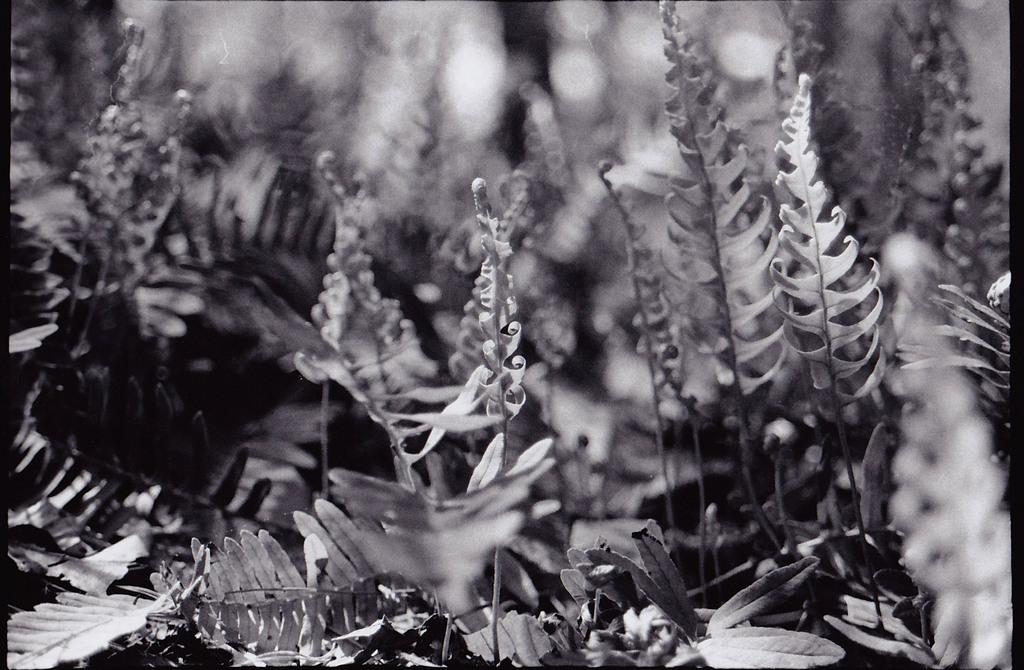What is the color scheme of the image? The image is black and white. What type of objects can be seen in the image? There are plants in the image. Can you describe the background of the image? The background of the image is blurred. What type of appliance is visible in the image? There is no appliance present in the image. What kind of cheese can be seen on the plants in the image? There is no cheese present in the image; it features plants in a black and white color scheme with a blurred background. 